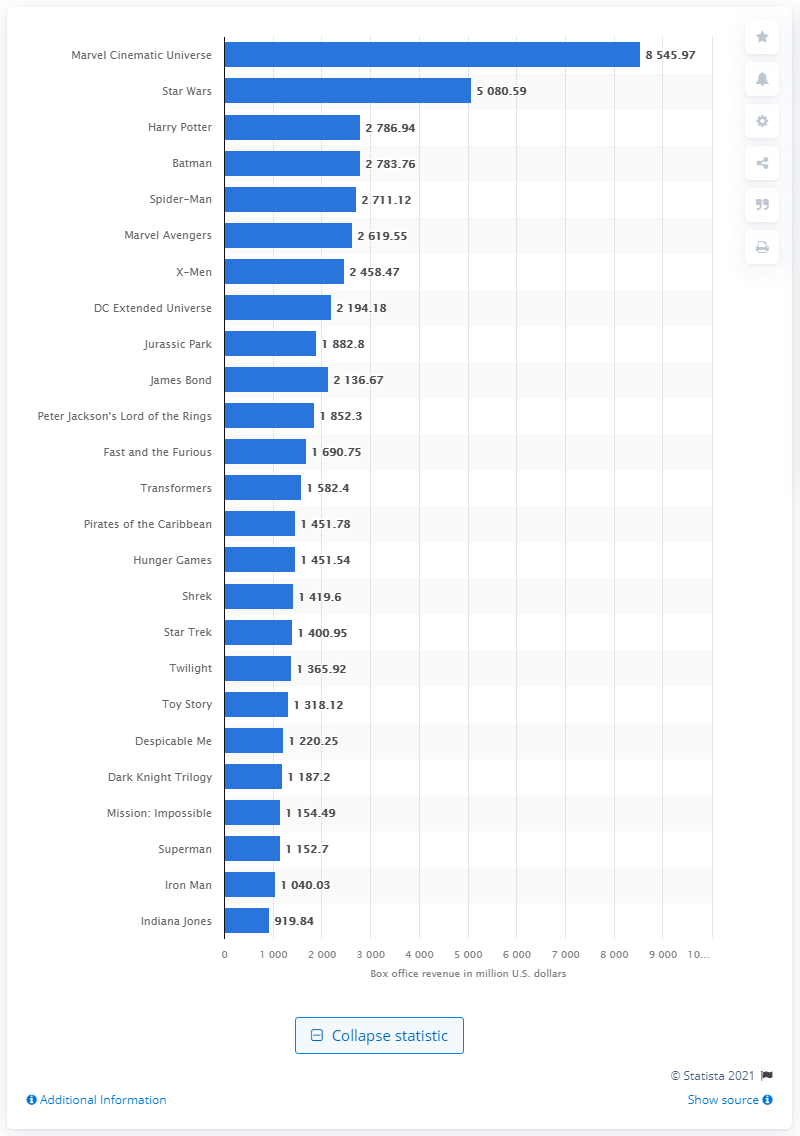Outline some significant characteristics in this image. The domestic box office revenue of the Marvel Cinematic Universe in 2021 was approximately $85,459.70. 